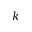Convert formula to latex. <formula><loc_0><loc_0><loc_500><loc_500>k</formula> 